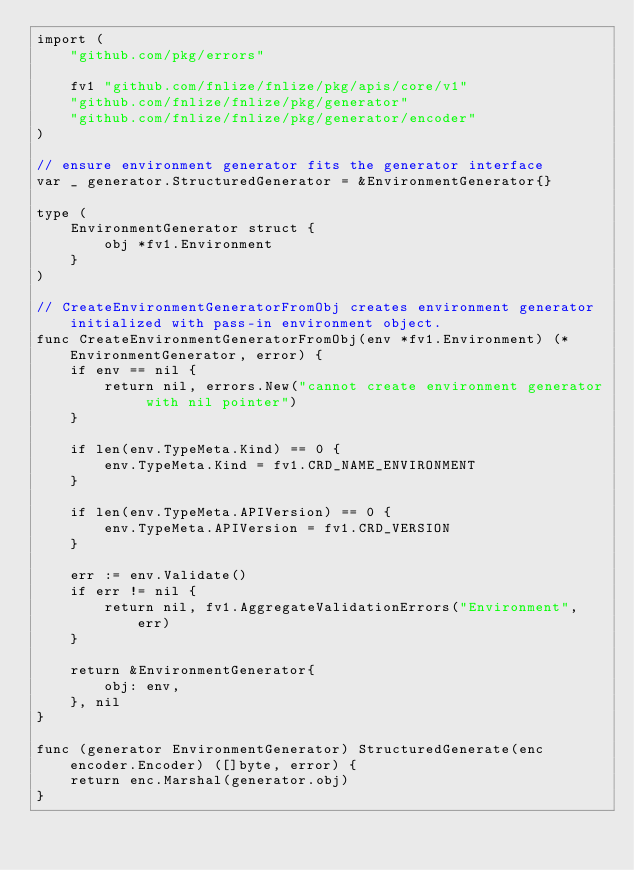Convert code to text. <code><loc_0><loc_0><loc_500><loc_500><_Go_>import (
	"github.com/pkg/errors"

	fv1 "github.com/fnlize/fnlize/pkg/apis/core/v1"
	"github.com/fnlize/fnlize/pkg/generator"
	"github.com/fnlize/fnlize/pkg/generator/encoder"
)

// ensure environment generator fits the generator interface
var _ generator.StructuredGenerator = &EnvironmentGenerator{}

type (
	EnvironmentGenerator struct {
		obj *fv1.Environment
	}
)

// CreateEnvironmentGeneratorFromObj creates environment generator initialized with pass-in environment object.
func CreateEnvironmentGeneratorFromObj(env *fv1.Environment) (*EnvironmentGenerator, error) {
	if env == nil {
		return nil, errors.New("cannot create environment generator with nil pointer")
	}

	if len(env.TypeMeta.Kind) == 0 {
		env.TypeMeta.Kind = fv1.CRD_NAME_ENVIRONMENT
	}

	if len(env.TypeMeta.APIVersion) == 0 {
		env.TypeMeta.APIVersion = fv1.CRD_VERSION
	}

	err := env.Validate()
	if err != nil {
		return nil, fv1.AggregateValidationErrors("Environment", err)
	}

	return &EnvironmentGenerator{
		obj: env,
	}, nil
}

func (generator EnvironmentGenerator) StructuredGenerate(enc encoder.Encoder) ([]byte, error) {
	return enc.Marshal(generator.obj)
}
</code> 